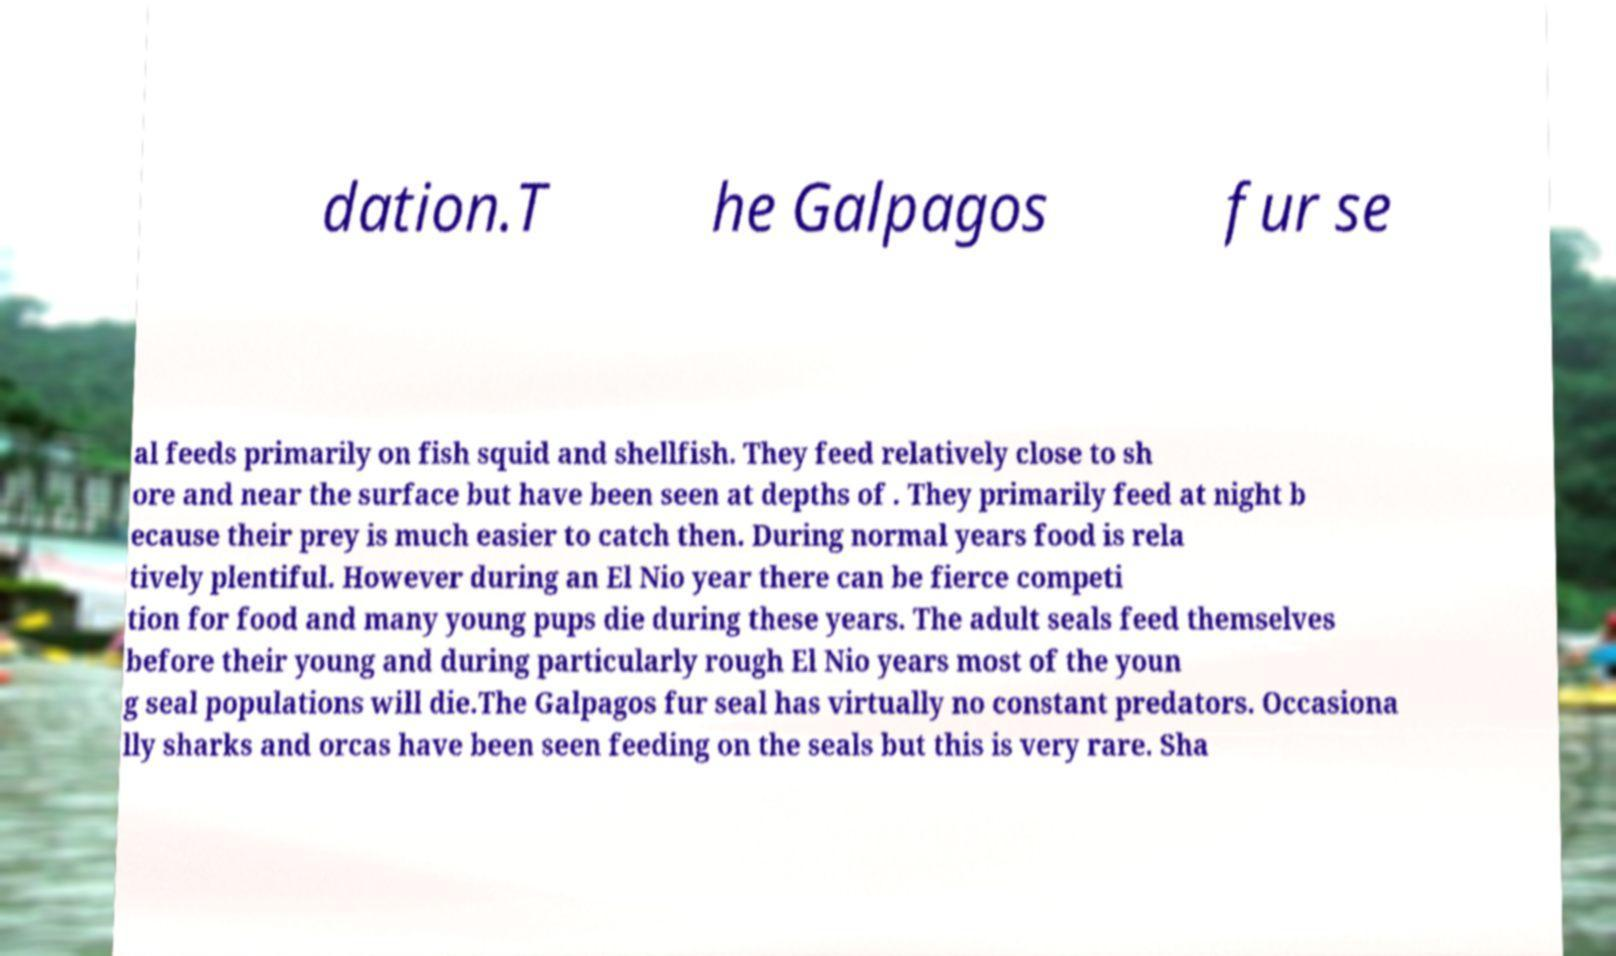What messages or text are displayed in this image? I need them in a readable, typed format. dation.T he Galpagos fur se al feeds primarily on fish squid and shellfish. They feed relatively close to sh ore and near the surface but have been seen at depths of . They primarily feed at night b ecause their prey is much easier to catch then. During normal years food is rela tively plentiful. However during an El Nio year there can be fierce competi tion for food and many young pups die during these years. The adult seals feed themselves before their young and during particularly rough El Nio years most of the youn g seal populations will die.The Galpagos fur seal has virtually no constant predators. Occasiona lly sharks and orcas have been seen feeding on the seals but this is very rare. Sha 